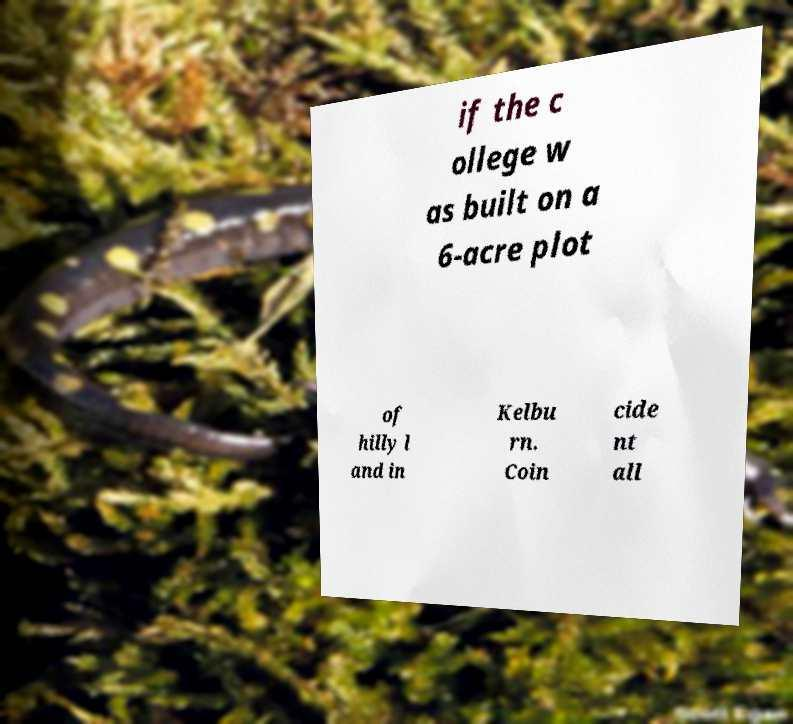Please read and relay the text visible in this image. What does it say? if the c ollege w as built on a 6-acre plot of hilly l and in Kelbu rn. Coin cide nt all 